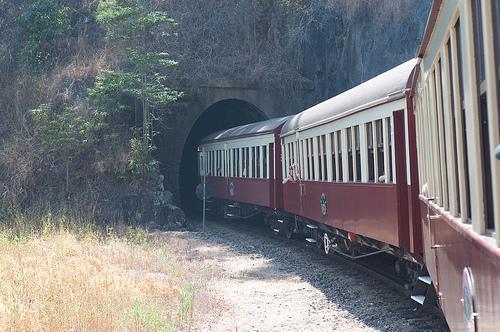How many train cars are visible in the photo?
Give a very brief answer. 3. 